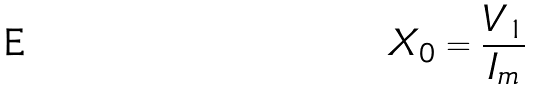Convert formula to latex. <formula><loc_0><loc_0><loc_500><loc_500>X _ { 0 } = \frac { V _ { 1 } } { I _ { m } }</formula> 